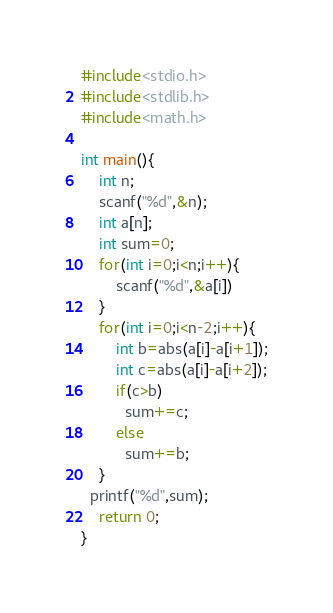Convert code to text. <code><loc_0><loc_0><loc_500><loc_500><_C_>#include<stdio.h>
#include<stdlib.h>
#include<math.h>

int main(){
  	int n;
  	scanf("%d",&n);
  	int a[n];
    int sum=0;
  	for(int i=0;i<n;i++){
    	scanf("%d",&a[i])
    }
  	for(int i=0;i<n-2;i++){
    	int b=abs(a[i]-a[i+1]);
      	int c=abs(a[i]-a[i+2]);
      	if(c>b)
          sum+=c;
      	else 
          sum+=b;
    }
  printf("%d",sum);
	return 0;
}</code> 